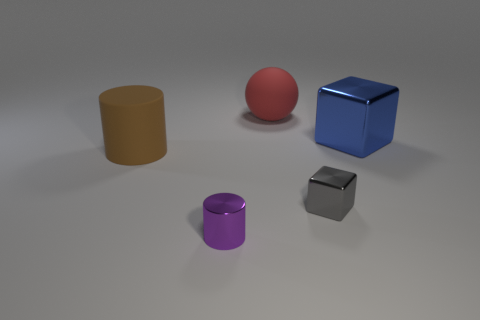What is the color of the big thing to the left of the small thing that is in front of the tiny gray block?
Your response must be concise. Brown. There is a large blue object that is the same shape as the gray metallic thing; what is its material?
Your response must be concise. Metal. How many gray shiny blocks have the same size as the purple metallic object?
Your answer should be compact. 1. The blue thing that is the same material as the tiny purple object is what size?
Provide a succinct answer. Large. How many large metal things are the same shape as the brown matte thing?
Provide a succinct answer. 0. What number of gray objects are there?
Your response must be concise. 1. There is a small thing that is left of the small gray shiny cube; is its shape the same as the big red matte thing?
Your answer should be very brief. No. There is a red object that is the same size as the brown matte thing; what is its material?
Offer a terse response. Rubber. Is there a small gray cube that has the same material as the purple thing?
Your answer should be compact. Yes. There is a brown rubber object; is its shape the same as the matte object behind the big blue cube?
Give a very brief answer. No. 